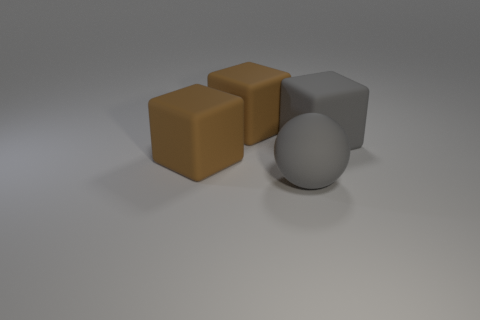The cube that is in front of the large object to the right of the big gray ball is made of what material?
Your answer should be very brief. Rubber. What is the color of the ball that is made of the same material as the big gray cube?
Offer a very short reply. Gray. There is a cube that is to the right of the matte sphere; what material is it?
Your answer should be very brief. Rubber. What is the thing that is in front of the big gray matte cube and on the left side of the big gray ball made of?
Keep it short and to the point. Rubber. What color is the matte sphere that is the same size as the gray cube?
Provide a short and direct response. Gray. Does the sphere have the same material as the cube in front of the large gray cube?
Offer a very short reply. Yes. What number of other objects are the same size as the gray rubber block?
Offer a terse response. 3. Are there any big rubber objects in front of the brown matte cube behind the big gray matte object that is behind the big matte ball?
Offer a terse response. Yes. The gray rubber cube is what size?
Keep it short and to the point. Large. There is a gray rubber thing that is left of the gray matte block; what size is it?
Keep it short and to the point. Large. 